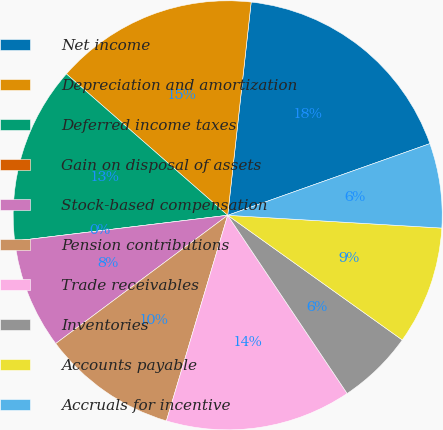Convert chart to OTSL. <chart><loc_0><loc_0><loc_500><loc_500><pie_chart><fcel>Net income<fcel>Depreciation and amortization<fcel>Deferred income taxes<fcel>Gain on disposal of assets<fcel>Stock-based compensation<fcel>Pension contributions<fcel>Trade receivables<fcel>Inventories<fcel>Accounts payable<fcel>Accruals for incentive<nl><fcel>17.83%<fcel>15.29%<fcel>13.37%<fcel>0.0%<fcel>8.28%<fcel>10.19%<fcel>14.01%<fcel>5.73%<fcel>8.92%<fcel>6.37%<nl></chart> 